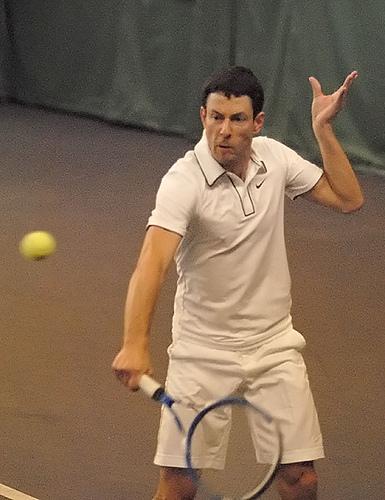What sport is this?
Keep it brief. Tennis. What letter is on the racket?
Short answer required. None. Does the man look frustrated?
Keep it brief. Yes. What color is the racquet?
Quick response, please. Blue. What game is being played?
Give a very brief answer. Tennis. Is the man about to hit a backhand shot?
Concise answer only. Yes. Is the man having fun?
Write a very short answer. Yes. What is the man throwing?
Keep it brief. Tennis ball. Is this person wearing a tie?
Give a very brief answer. No. Does this man look like a pro?
Give a very brief answer. Yes. Who will win?
Be succinct. Man. Which hand is the racket being held in?
Concise answer only. Right. What color is that racket?
Give a very brief answer. Blue. What color is this man's shirt?
Give a very brief answer. White. Why is the man holding a racquet?
Answer briefly. Playing tennis. What color is his shirt?
Be succinct. White. Does he look happy?
Keep it brief. No. Is the player wearing a headband?
Concise answer only. No. Is the man squatting?
Keep it brief. No. Is the player sponsored by adidas?
Short answer required. No. How many wristbands does the man have on?
Keep it brief. 0. Are the man's shoes tied?
Write a very short answer. Yes. How many balls are there?
Write a very short answer. 1. How many tennis rackets are in this scene?
Short answer required. 1. Is he wearing a headband?
Be succinct. No. Does the man have markings on his body?
Write a very short answer. No. Is the man wearing pants?
Give a very brief answer. No. What color is his racket?
Concise answer only. Blue. Is the guy good at the sport?
Answer briefly. Yes. Is he making a big effort to win the match?
Keep it brief. Yes. What is the man about to do?
Be succinct. Hit ball. What color are the man's shorts?
Write a very short answer. White. How many of his fingers are extended?
Answer briefly. 5. What brand of shirt is the player wearing?
Short answer required. Nike. Is this a man?
Answer briefly. Yes. 